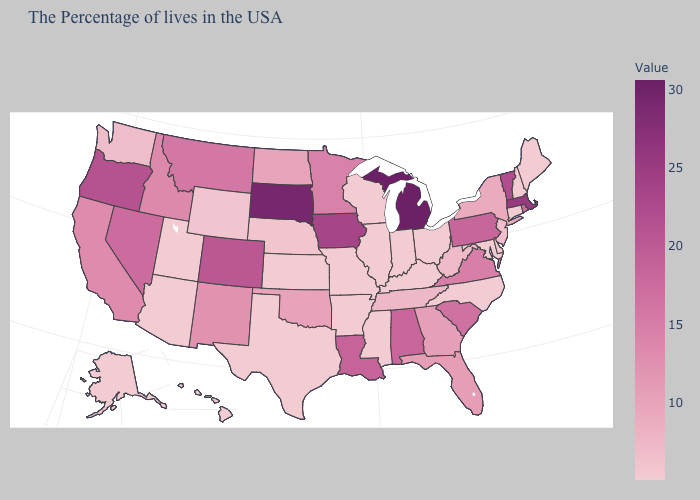Which states hav the highest value in the West?
Answer briefly. Oregon. Which states have the lowest value in the MidWest?
Keep it brief. Ohio, Indiana, Wisconsin, Illinois, Missouri, Kansas. Which states have the highest value in the USA?
Keep it brief. Michigan. Among the states that border Maryland , which have the lowest value?
Keep it brief. Delaware. Which states hav the highest value in the South?
Short answer required. Louisiana. Does New Hampshire have a lower value than Massachusetts?
Give a very brief answer. Yes. Does New Jersey have the lowest value in the Northeast?
Be succinct. No. 